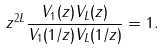<formula> <loc_0><loc_0><loc_500><loc_500>z ^ { 2 L } \frac { V _ { 1 } ( z ) V _ { L } ( z ) } { V _ { 1 } ( 1 / z ) V _ { L } ( 1 / z ) } = 1 .</formula> 